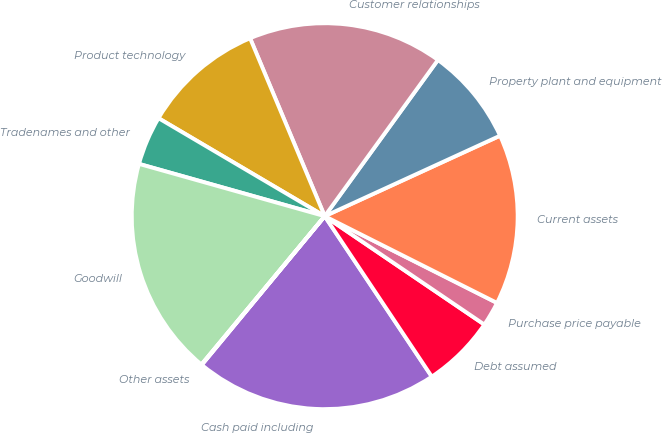<chart> <loc_0><loc_0><loc_500><loc_500><pie_chart><fcel>Cash paid including<fcel>Debt assumed<fcel>Purchase price payable<fcel>Current assets<fcel>Property plant and equipment<fcel>Customer relationships<fcel>Product technology<fcel>Tradenames and other<fcel>Goodwill<fcel>Other assets<nl><fcel>20.36%<fcel>6.14%<fcel>2.07%<fcel>14.27%<fcel>8.17%<fcel>16.3%<fcel>10.2%<fcel>4.11%<fcel>18.33%<fcel>0.04%<nl></chart> 